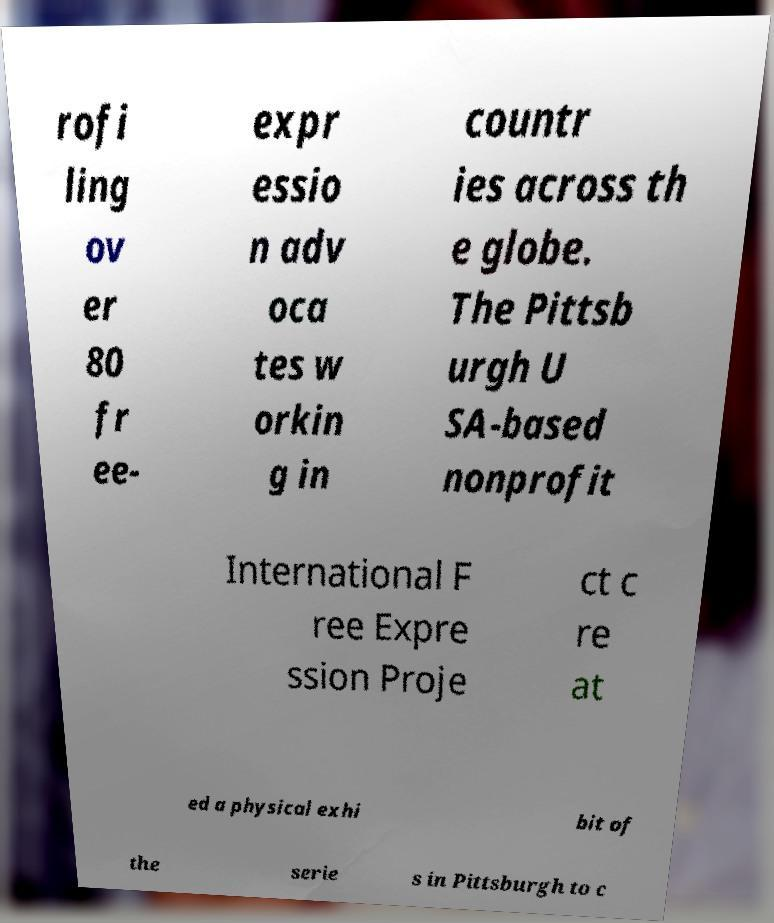Can you accurately transcribe the text from the provided image for me? rofi ling ov er 80 fr ee- expr essio n adv oca tes w orkin g in countr ies across th e globe. The Pittsb urgh U SA-based nonprofit International F ree Expre ssion Proje ct c re at ed a physical exhi bit of the serie s in Pittsburgh to c 